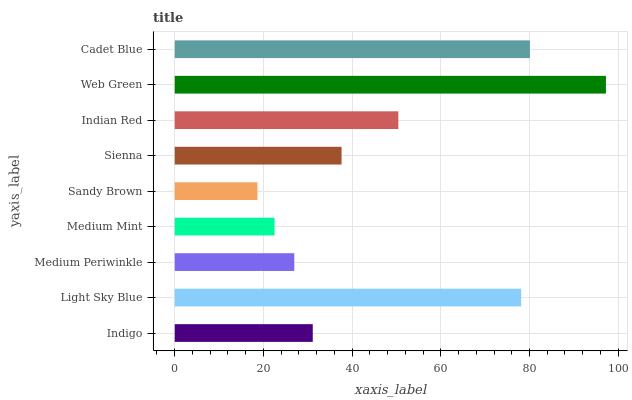Is Sandy Brown the minimum?
Answer yes or no. Yes. Is Web Green the maximum?
Answer yes or no. Yes. Is Light Sky Blue the minimum?
Answer yes or no. No. Is Light Sky Blue the maximum?
Answer yes or no. No. Is Light Sky Blue greater than Indigo?
Answer yes or no. Yes. Is Indigo less than Light Sky Blue?
Answer yes or no. Yes. Is Indigo greater than Light Sky Blue?
Answer yes or no. No. Is Light Sky Blue less than Indigo?
Answer yes or no. No. Is Sienna the high median?
Answer yes or no. Yes. Is Sienna the low median?
Answer yes or no. Yes. Is Light Sky Blue the high median?
Answer yes or no. No. Is Medium Mint the low median?
Answer yes or no. No. 